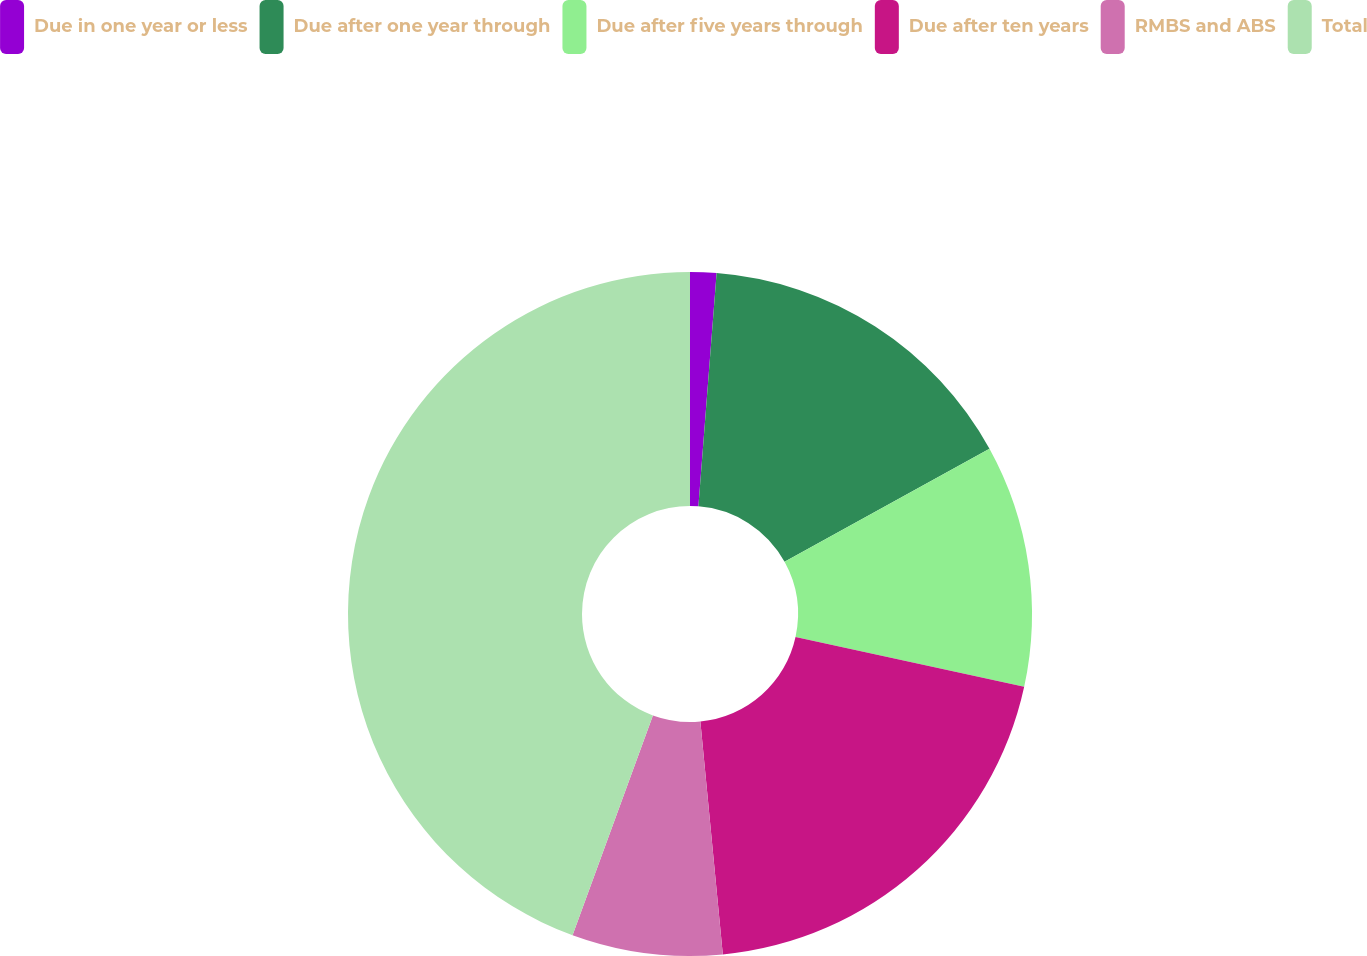Convert chart to OTSL. <chart><loc_0><loc_0><loc_500><loc_500><pie_chart><fcel>Due in one year or less<fcel>Due after one year through<fcel>Due after five years through<fcel>Due after ten years<fcel>RMBS and ABS<fcel>Total<nl><fcel>1.24%<fcel>15.74%<fcel>11.43%<fcel>20.06%<fcel>7.11%<fcel>44.42%<nl></chart> 